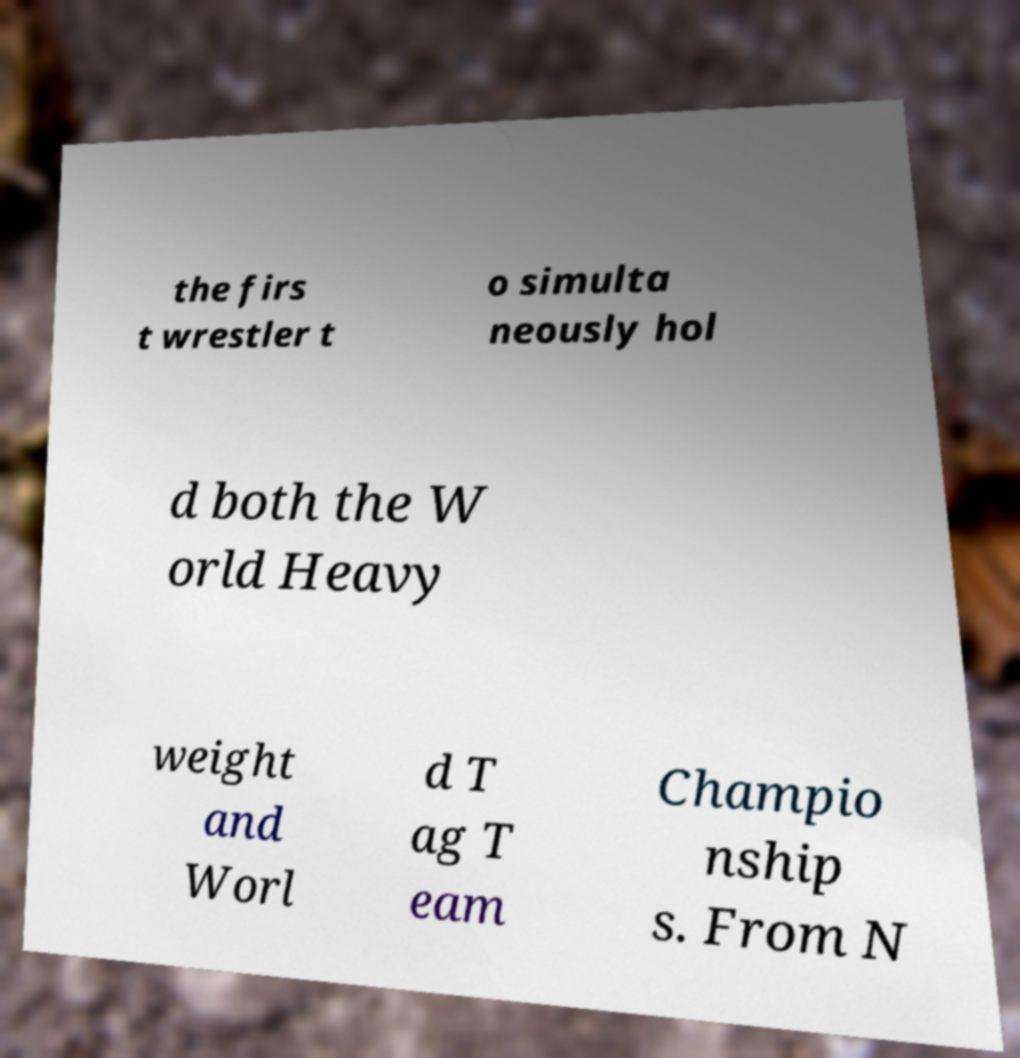Could you extract and type out the text from this image? the firs t wrestler t o simulta neously hol d both the W orld Heavy weight and Worl d T ag T eam Champio nship s. From N 